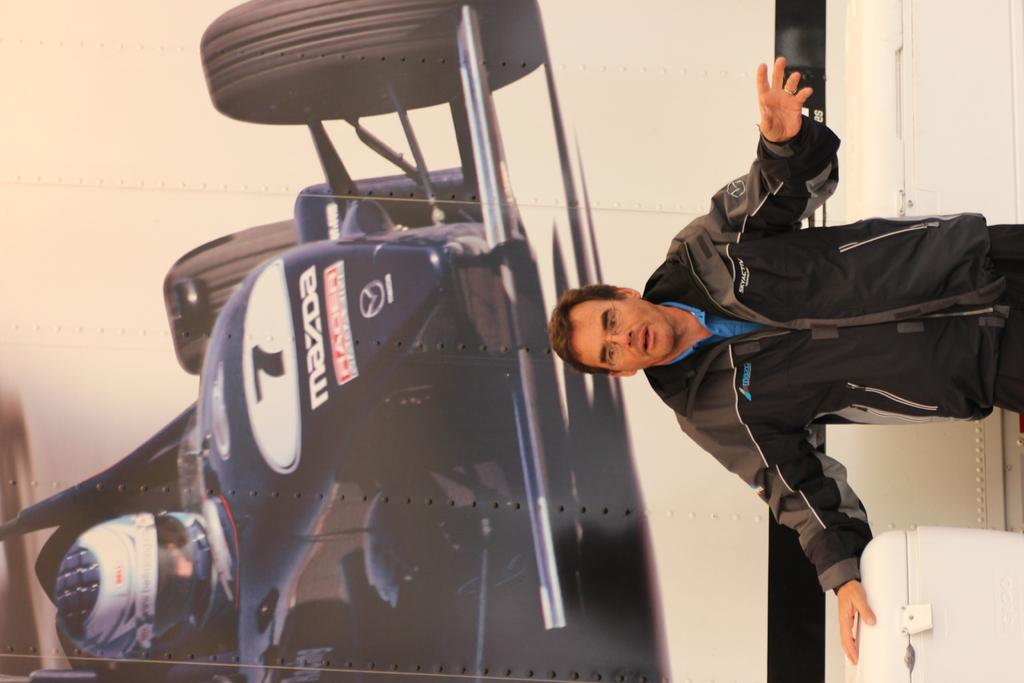<image>
Provide a brief description of the given image. A person is giving speech with a mazda racing car at the background. 